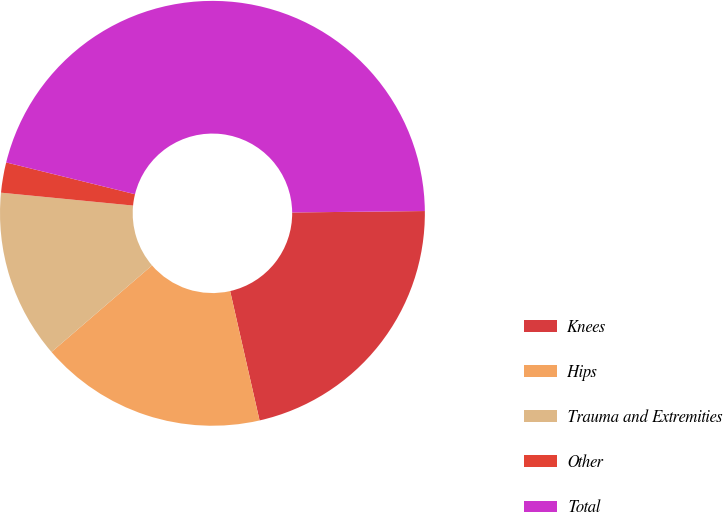<chart> <loc_0><loc_0><loc_500><loc_500><pie_chart><fcel>Knees<fcel>Hips<fcel>Trauma and Extremities<fcel>Other<fcel>Total<nl><fcel>21.61%<fcel>17.24%<fcel>12.87%<fcel>2.3%<fcel>45.98%<nl></chart> 